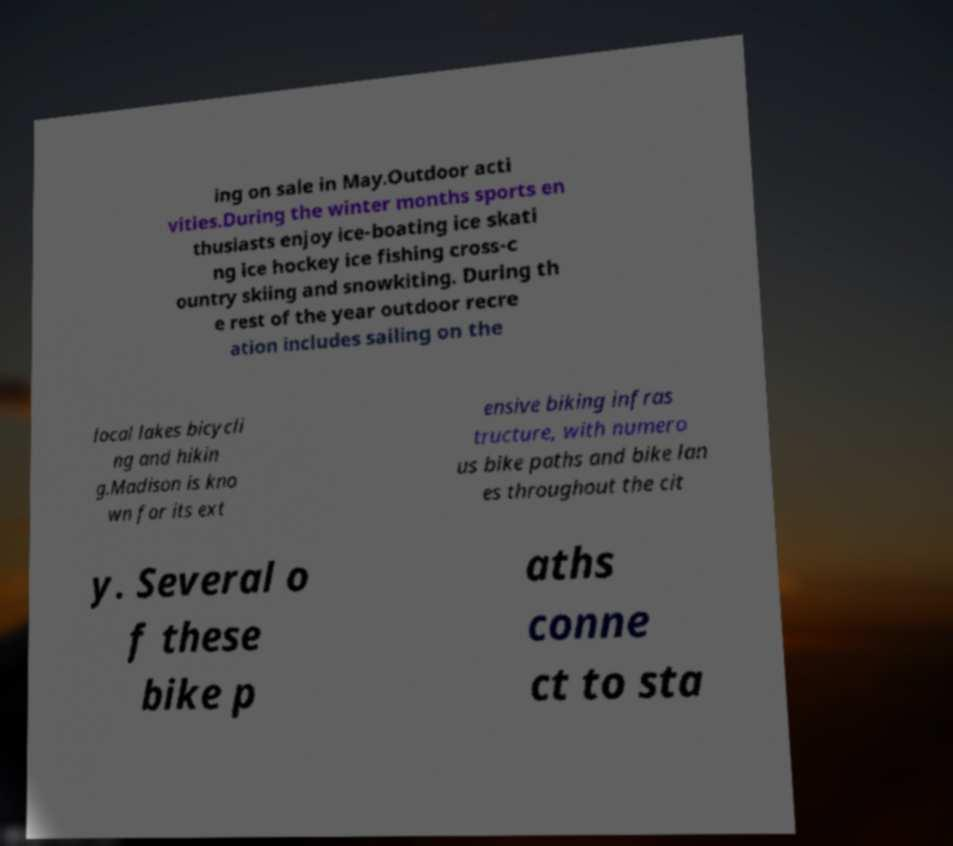There's text embedded in this image that I need extracted. Can you transcribe it verbatim? ing on sale in May.Outdoor acti vities.During the winter months sports en thusiasts enjoy ice-boating ice skati ng ice hockey ice fishing cross-c ountry skiing and snowkiting. During th e rest of the year outdoor recre ation includes sailing on the local lakes bicycli ng and hikin g.Madison is kno wn for its ext ensive biking infras tructure, with numero us bike paths and bike lan es throughout the cit y. Several o f these bike p aths conne ct to sta 